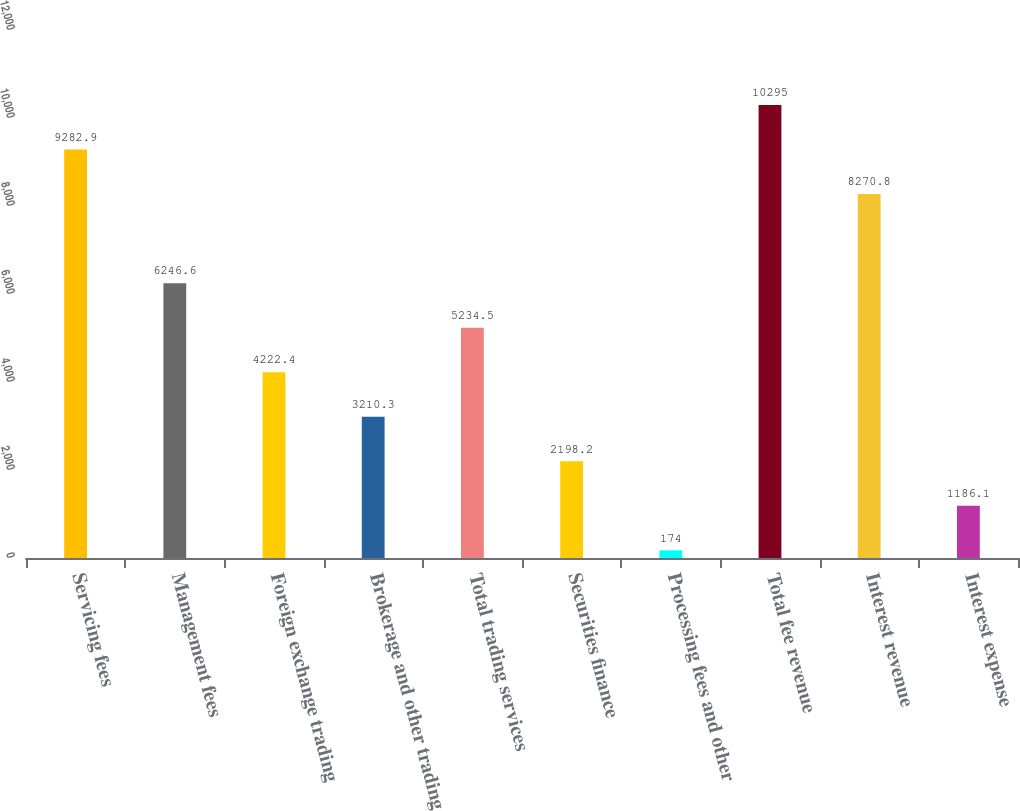Convert chart. <chart><loc_0><loc_0><loc_500><loc_500><bar_chart><fcel>Servicing fees<fcel>Management fees<fcel>Foreign exchange trading<fcel>Brokerage and other trading<fcel>Total trading services<fcel>Securities finance<fcel>Processing fees and other<fcel>Total fee revenue<fcel>Interest revenue<fcel>Interest expense<nl><fcel>9282.9<fcel>6246.6<fcel>4222.4<fcel>3210.3<fcel>5234.5<fcel>2198.2<fcel>174<fcel>10295<fcel>8270.8<fcel>1186.1<nl></chart> 